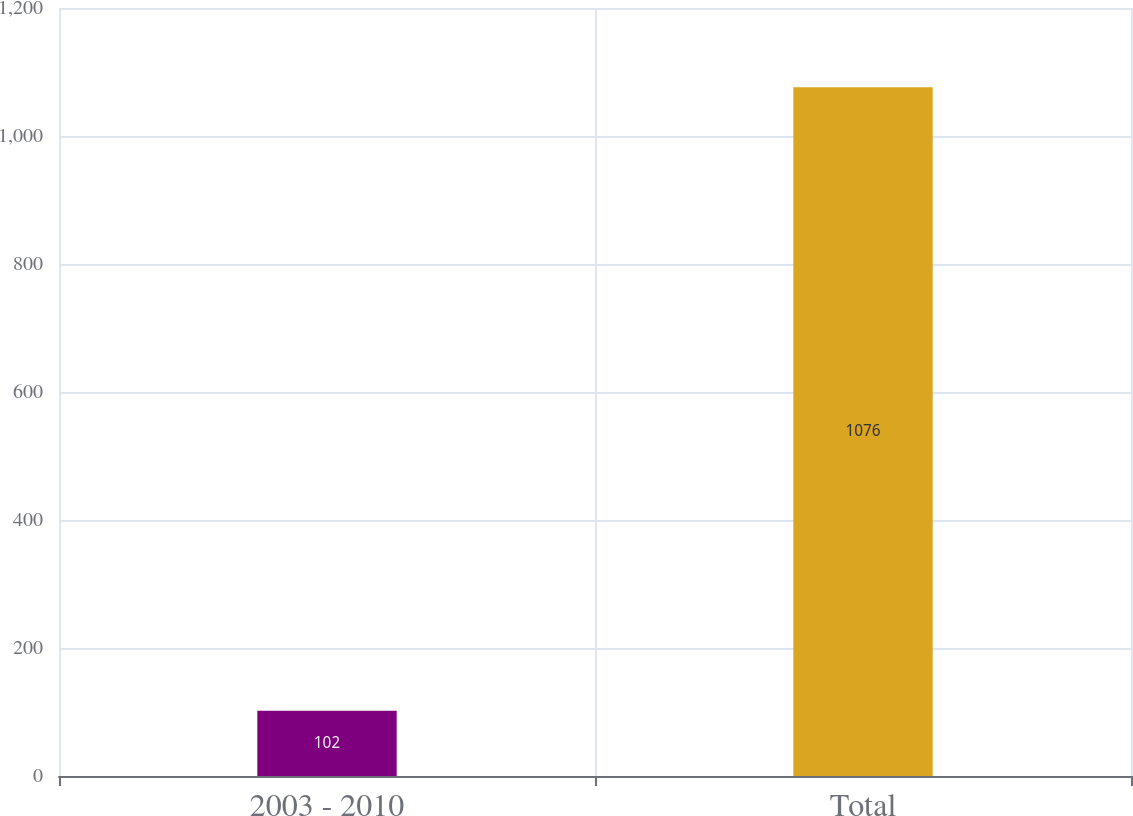<chart> <loc_0><loc_0><loc_500><loc_500><bar_chart><fcel>2003 - 2010<fcel>Total<nl><fcel>102<fcel>1076<nl></chart> 